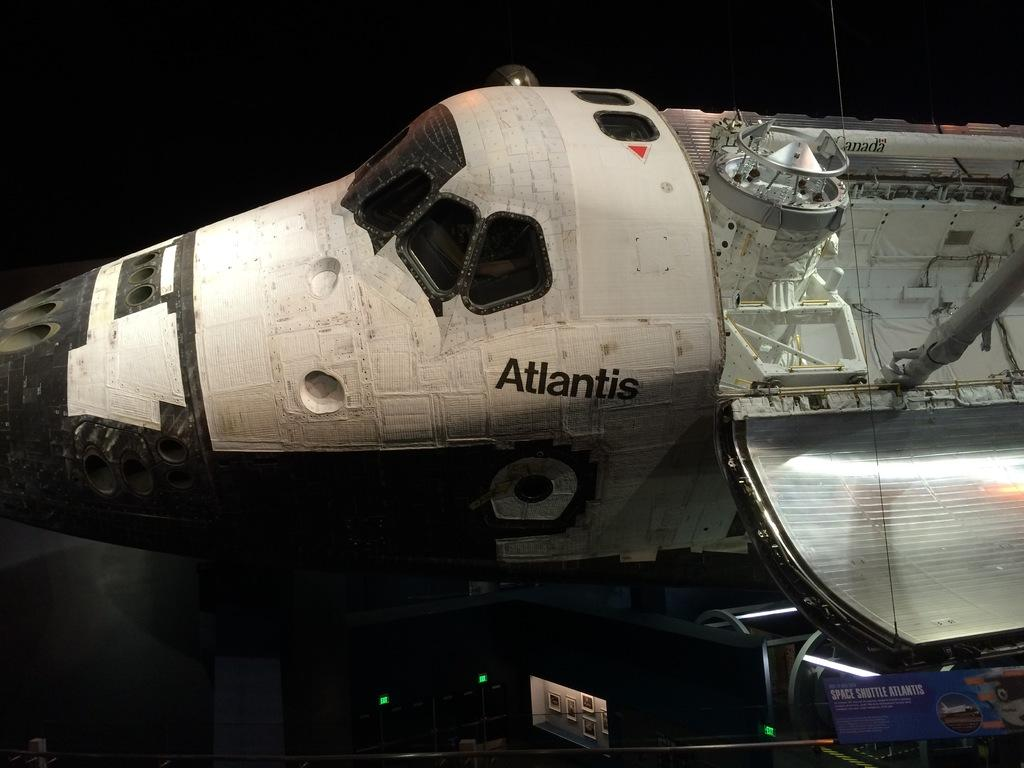<image>
Present a compact description of the photo's key features. A space shuttle called Atlantis is on display at a museum. 